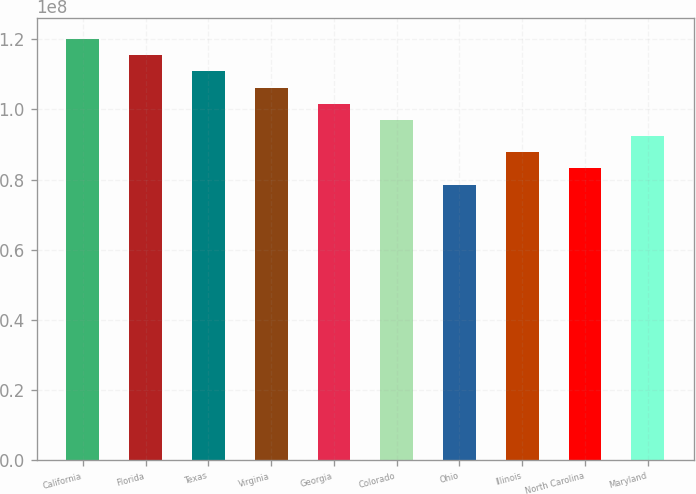Convert chart to OTSL. <chart><loc_0><loc_0><loc_500><loc_500><bar_chart><fcel>California<fcel>Florida<fcel>Texas<fcel>Virginia<fcel>Georgia<fcel>Colorado<fcel>Ohio<fcel>Illinois<fcel>North Carolina<fcel>Maryland<nl><fcel>1.20083e+08<fcel>1.15468e+08<fcel>1.10853e+08<fcel>1.06238e+08<fcel>1.01623e+08<fcel>9.70077e+07<fcel>7.85479e+07<fcel>8.77778e+07<fcel>8.31628e+07<fcel>9.23928e+07<nl></chart> 